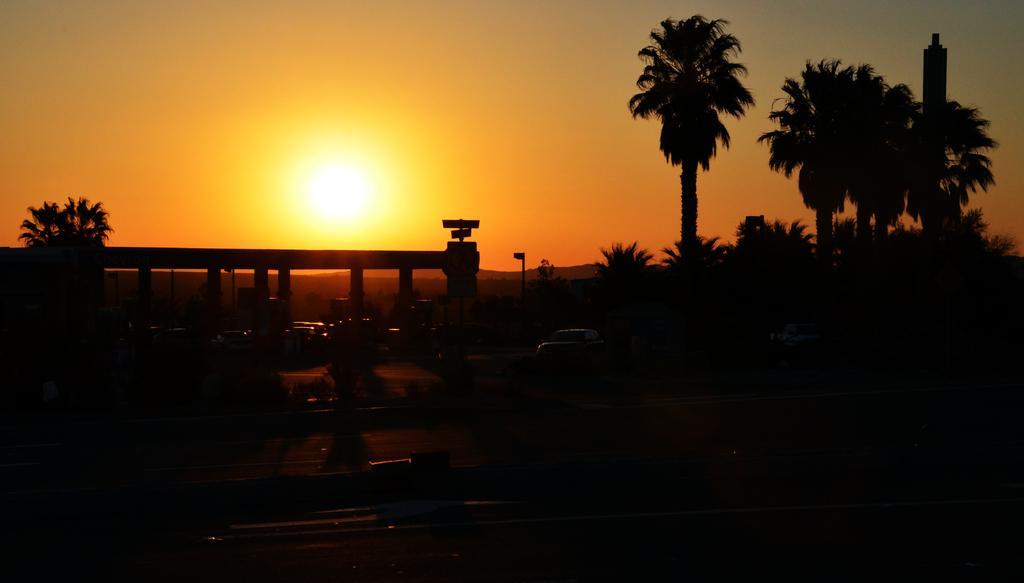Could you give a brief overview of what you see in this image? In this image I can see the dark picture in which I can see the road, few vehicles, few trees and in the background I can see the sky and the sun. 